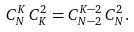<formula> <loc_0><loc_0><loc_500><loc_500>C _ { N } ^ { K } \, C _ { K } ^ { 2 } = C _ { N - 2 } ^ { K - 2 } \, C _ { N } ^ { 2 } .</formula> 